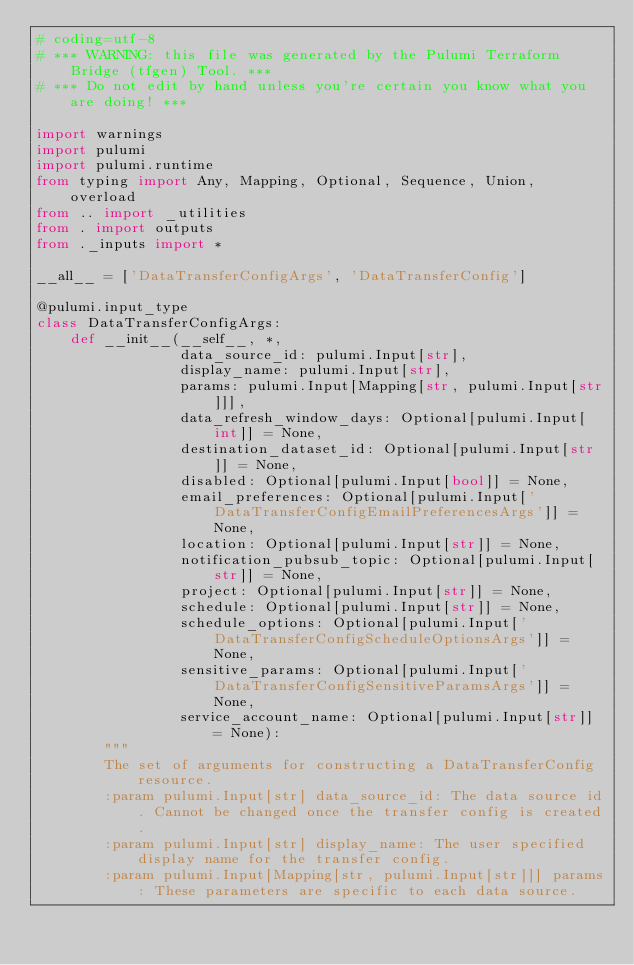<code> <loc_0><loc_0><loc_500><loc_500><_Python_># coding=utf-8
# *** WARNING: this file was generated by the Pulumi Terraform Bridge (tfgen) Tool. ***
# *** Do not edit by hand unless you're certain you know what you are doing! ***

import warnings
import pulumi
import pulumi.runtime
from typing import Any, Mapping, Optional, Sequence, Union, overload
from .. import _utilities
from . import outputs
from ._inputs import *

__all__ = ['DataTransferConfigArgs', 'DataTransferConfig']

@pulumi.input_type
class DataTransferConfigArgs:
    def __init__(__self__, *,
                 data_source_id: pulumi.Input[str],
                 display_name: pulumi.Input[str],
                 params: pulumi.Input[Mapping[str, pulumi.Input[str]]],
                 data_refresh_window_days: Optional[pulumi.Input[int]] = None,
                 destination_dataset_id: Optional[pulumi.Input[str]] = None,
                 disabled: Optional[pulumi.Input[bool]] = None,
                 email_preferences: Optional[pulumi.Input['DataTransferConfigEmailPreferencesArgs']] = None,
                 location: Optional[pulumi.Input[str]] = None,
                 notification_pubsub_topic: Optional[pulumi.Input[str]] = None,
                 project: Optional[pulumi.Input[str]] = None,
                 schedule: Optional[pulumi.Input[str]] = None,
                 schedule_options: Optional[pulumi.Input['DataTransferConfigScheduleOptionsArgs']] = None,
                 sensitive_params: Optional[pulumi.Input['DataTransferConfigSensitiveParamsArgs']] = None,
                 service_account_name: Optional[pulumi.Input[str]] = None):
        """
        The set of arguments for constructing a DataTransferConfig resource.
        :param pulumi.Input[str] data_source_id: The data source id. Cannot be changed once the transfer config is created.
        :param pulumi.Input[str] display_name: The user specified display name for the transfer config.
        :param pulumi.Input[Mapping[str, pulumi.Input[str]]] params: These parameters are specific to each data source.</code> 